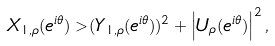Convert formula to latex. <formula><loc_0><loc_0><loc_500><loc_500>X _ { 1 , \rho } ( e ^ { i \theta } ) > ( Y _ { 1 , \rho } ( e ^ { i \theta } ) ) ^ { 2 } + \left | U _ { \rho } ( e ^ { i \theta } ) \right | ^ { 2 } ,</formula> 